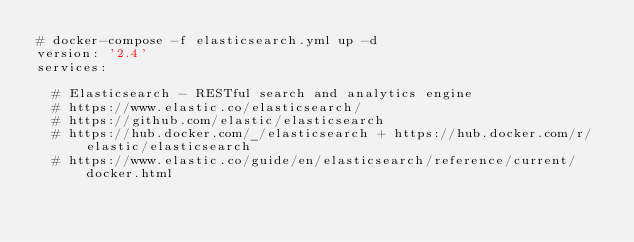Convert code to text. <code><loc_0><loc_0><loc_500><loc_500><_YAML_># docker-compose -f elasticsearch.yml up -d
version: '2.4'
services:
  
  # Elasticsearch - RESTful search and analytics engine
  # https://www.elastic.co/elasticsearch/
  # https://github.com/elastic/elasticsearch
  # https://hub.docker.com/_/elasticsearch + https://hub.docker.com/r/elastic/elasticsearch
  # https://www.elastic.co/guide/en/elasticsearch/reference/current/docker.html</code> 